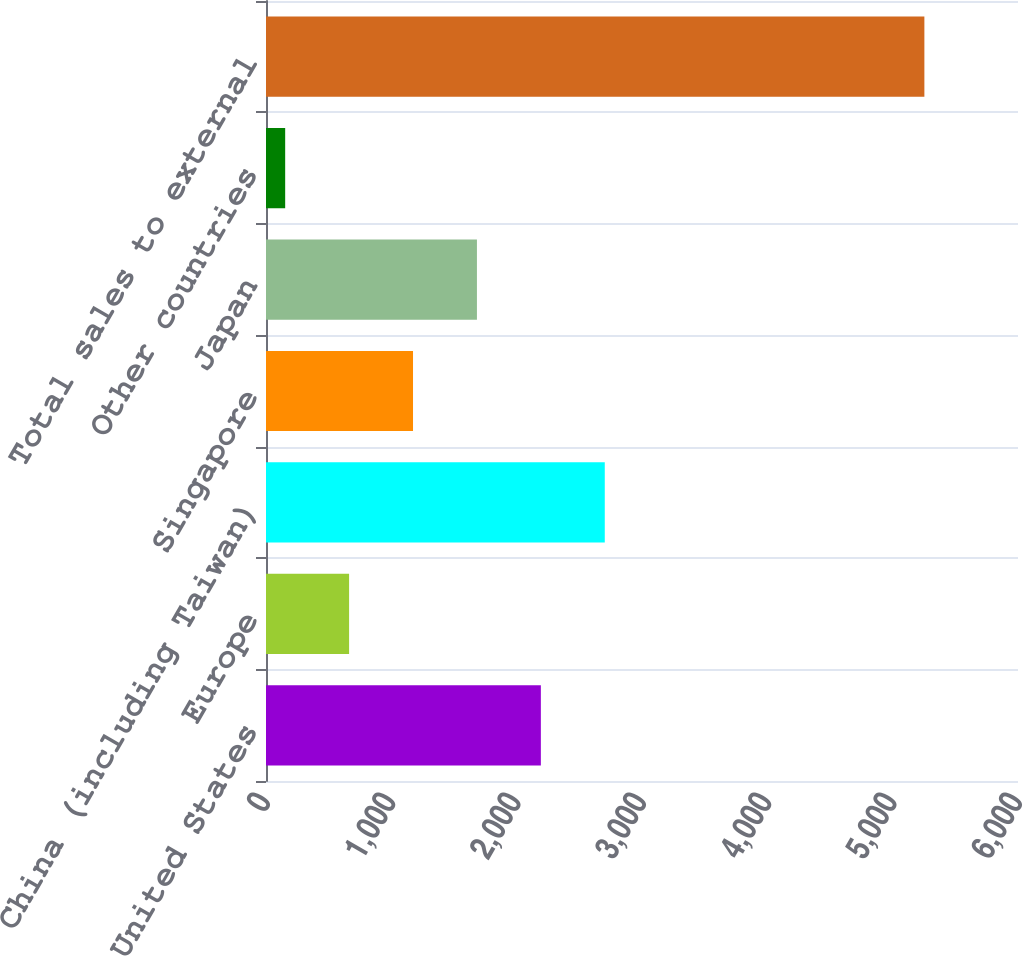Convert chart to OTSL. <chart><loc_0><loc_0><loc_500><loc_500><bar_chart><fcel>United States<fcel>Europe<fcel>China (including Taiwan)<fcel>Singapore<fcel>Japan<fcel>Other countries<fcel>Total sales to external<nl><fcel>2193<fcel>663<fcel>2703<fcel>1173<fcel>1683<fcel>153<fcel>5253<nl></chart> 